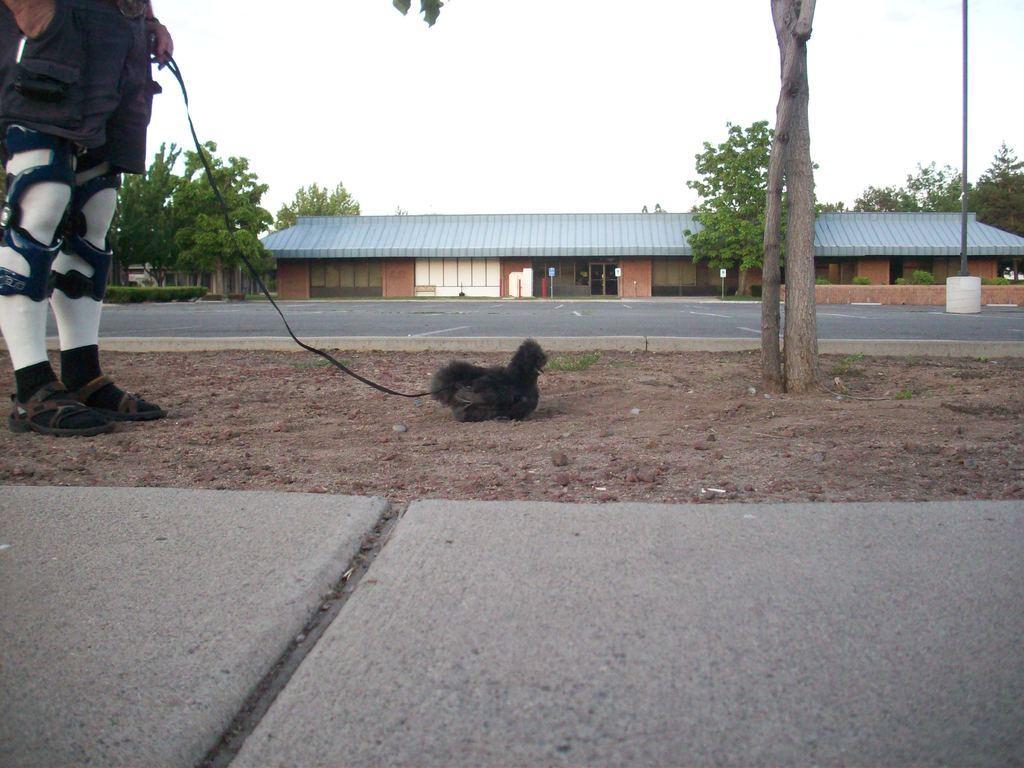Could you give a brief overview of what you see in this image? In this picture there is a person standing in the left corner and holding a belt in his hand which is tightened to a dog in front of him and there is a building and trees in the background. 